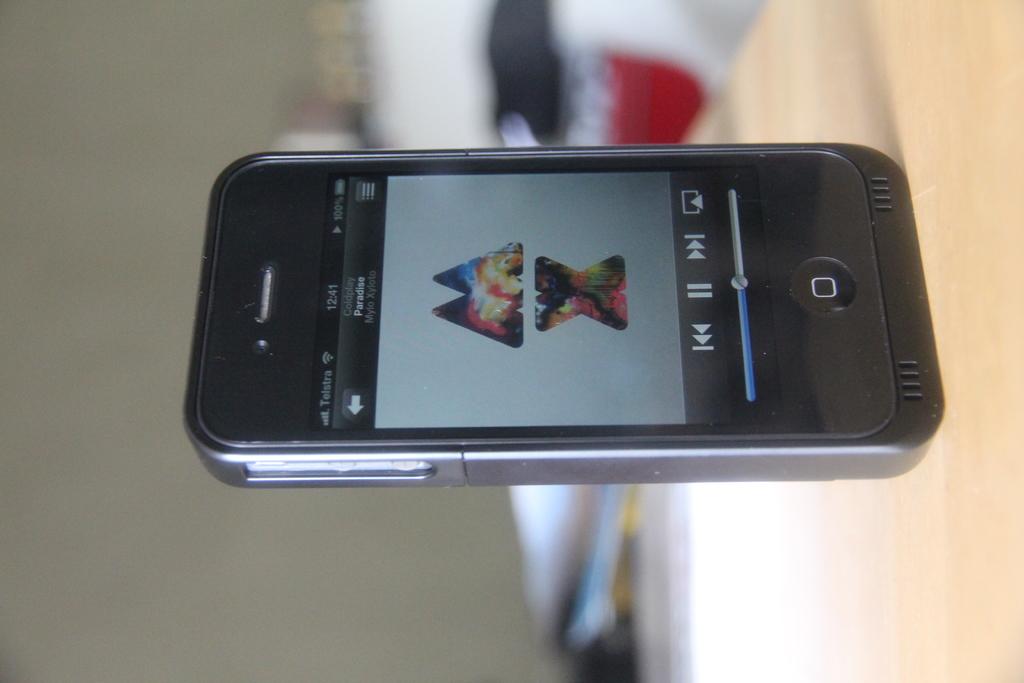What are they listening to?
Ensure brevity in your answer.  Paradise. What time is it on the phone?
Offer a terse response. 12:41. 